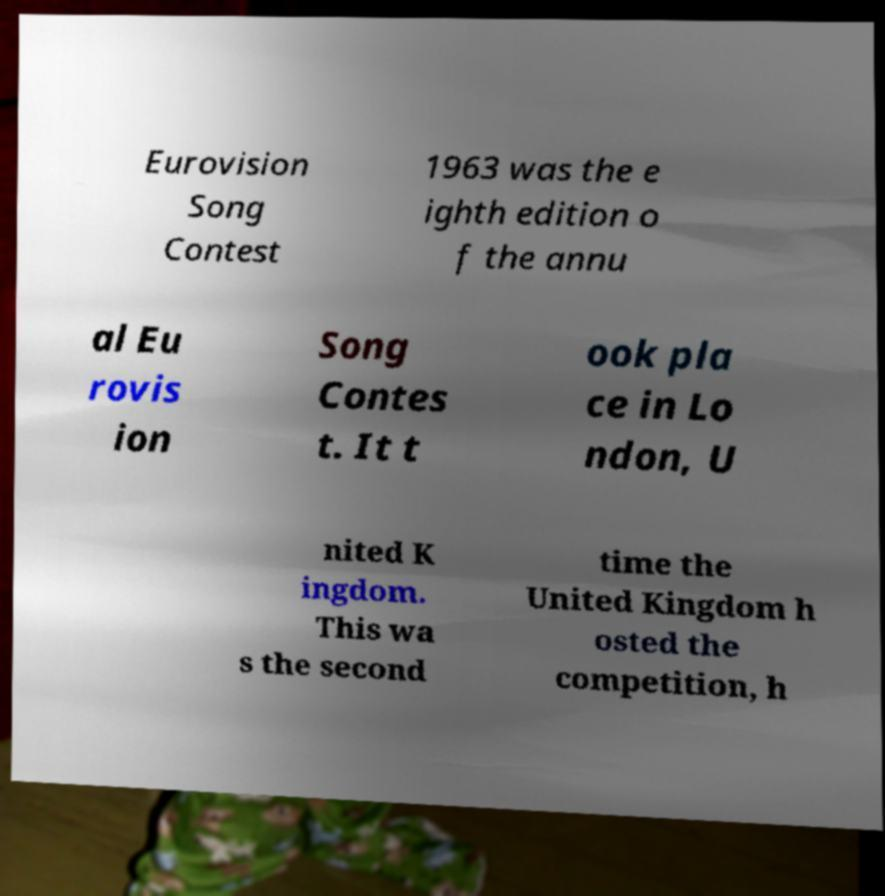Can you read and provide the text displayed in the image?This photo seems to have some interesting text. Can you extract and type it out for me? Eurovision Song Contest 1963 was the e ighth edition o f the annu al Eu rovis ion Song Contes t. It t ook pla ce in Lo ndon, U nited K ingdom. This wa s the second time the United Kingdom h osted the competition, h 